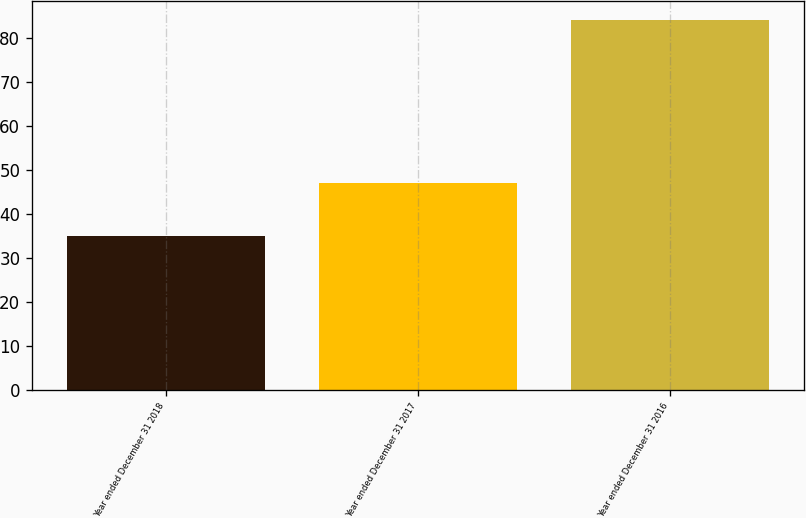Convert chart to OTSL. <chart><loc_0><loc_0><loc_500><loc_500><bar_chart><fcel>Year ended December 31 2018<fcel>Year ended December 31 2017<fcel>Year ended December 31 2016<nl><fcel>35<fcel>47<fcel>84<nl></chart> 